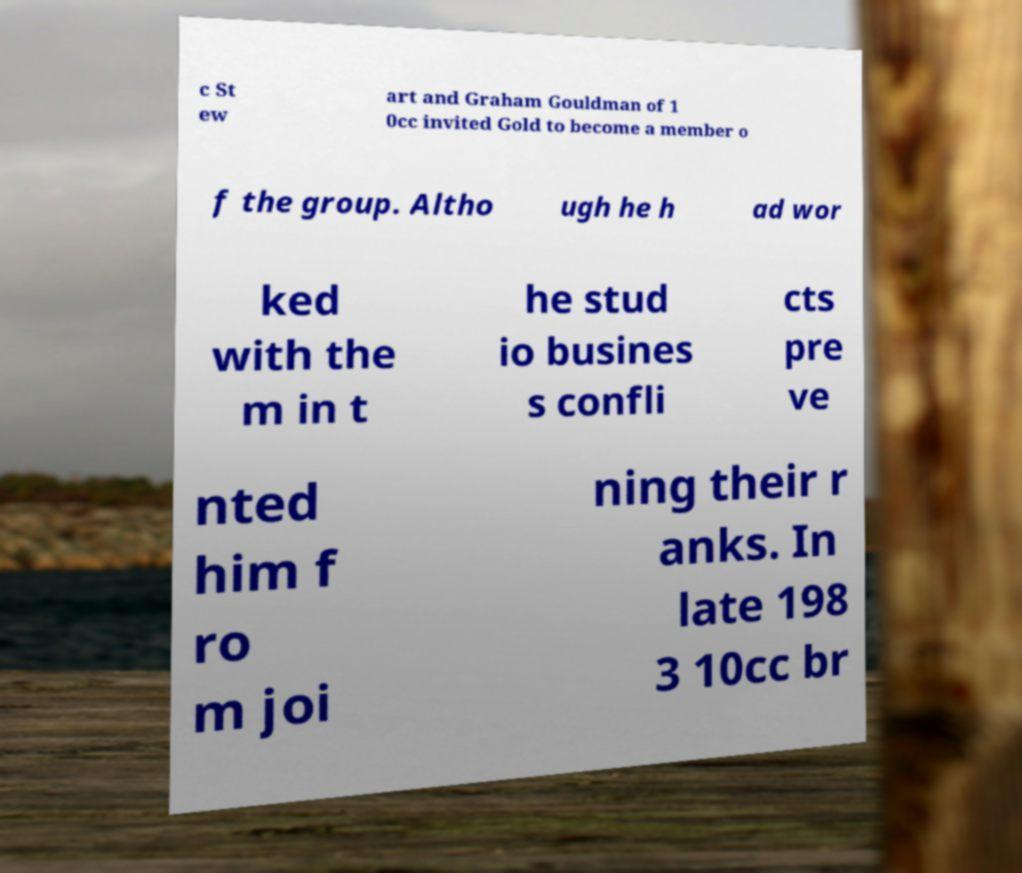Could you assist in decoding the text presented in this image and type it out clearly? c St ew art and Graham Gouldman of 1 0cc invited Gold to become a member o f the group. Altho ugh he h ad wor ked with the m in t he stud io busines s confli cts pre ve nted him f ro m joi ning their r anks. In late 198 3 10cc br 